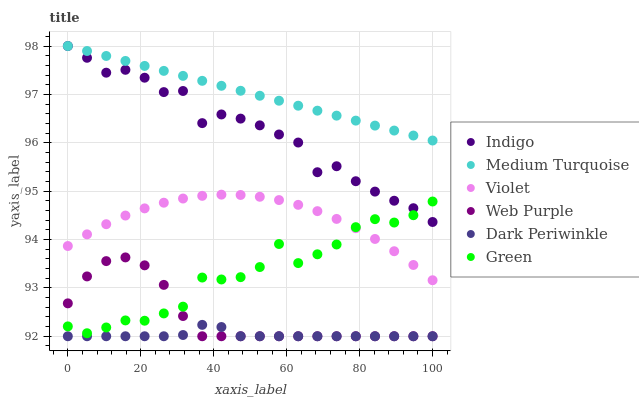Does Dark Periwinkle have the minimum area under the curve?
Answer yes or no. Yes. Does Medium Turquoise have the maximum area under the curve?
Answer yes or no. Yes. Does Web Purple have the minimum area under the curve?
Answer yes or no. No. Does Web Purple have the maximum area under the curve?
Answer yes or no. No. Is Medium Turquoise the smoothest?
Answer yes or no. Yes. Is Indigo the roughest?
Answer yes or no. Yes. Is Web Purple the smoothest?
Answer yes or no. No. Is Web Purple the roughest?
Answer yes or no. No. Does Web Purple have the lowest value?
Answer yes or no. Yes. Does Green have the lowest value?
Answer yes or no. No. Does Medium Turquoise have the highest value?
Answer yes or no. Yes. Does Web Purple have the highest value?
Answer yes or no. No. Is Violet less than Medium Turquoise?
Answer yes or no. Yes. Is Violet greater than Web Purple?
Answer yes or no. Yes. Does Indigo intersect Medium Turquoise?
Answer yes or no. Yes. Is Indigo less than Medium Turquoise?
Answer yes or no. No. Is Indigo greater than Medium Turquoise?
Answer yes or no. No. Does Violet intersect Medium Turquoise?
Answer yes or no. No. 